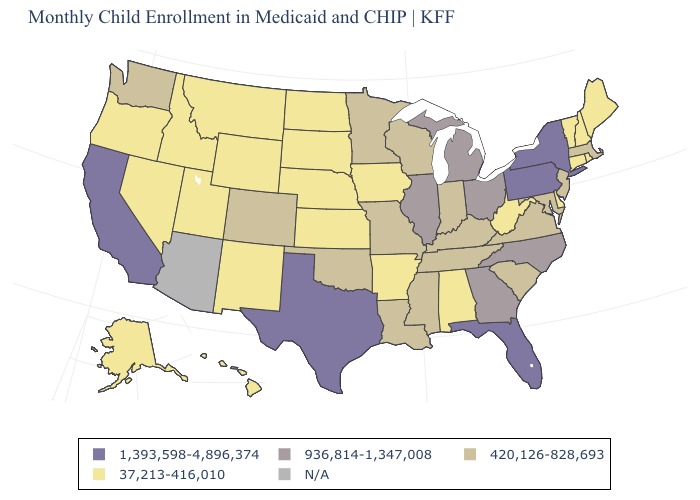Name the states that have a value in the range 420,126-828,693?
Short answer required. Colorado, Indiana, Kentucky, Louisiana, Maryland, Massachusetts, Minnesota, Mississippi, Missouri, New Jersey, Oklahoma, South Carolina, Tennessee, Virginia, Washington, Wisconsin. Name the states that have a value in the range 1,393,598-4,896,374?
Quick response, please. California, Florida, New York, Pennsylvania, Texas. What is the value of Maryland?
Write a very short answer. 420,126-828,693. Does Vermont have the highest value in the USA?
Keep it brief. No. Does Wyoming have the lowest value in the West?
Quick response, please. Yes. What is the value of South Carolina?
Give a very brief answer. 420,126-828,693. Does Michigan have the highest value in the MidWest?
Keep it brief. Yes. Name the states that have a value in the range 936,814-1,347,008?
Keep it brief. Georgia, Illinois, Michigan, North Carolina, Ohio. Name the states that have a value in the range 1,393,598-4,896,374?
Be succinct. California, Florida, New York, Pennsylvania, Texas. Does the first symbol in the legend represent the smallest category?
Give a very brief answer. No. What is the value of New Jersey?
Short answer required. 420,126-828,693. What is the value of Kentucky?
Answer briefly. 420,126-828,693. Does Illinois have the lowest value in the USA?
Short answer required. No. Name the states that have a value in the range N/A?
Keep it brief. Arizona. 